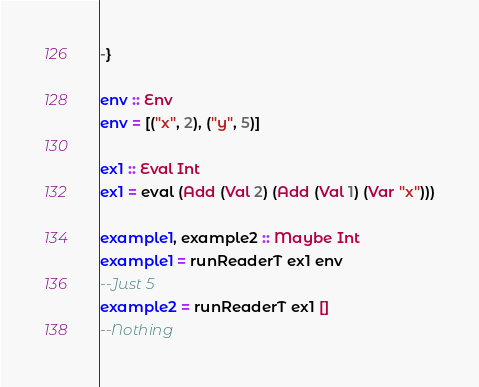Convert code to text. <code><loc_0><loc_0><loc_500><loc_500><_Haskell_>-}

env :: Env
env = [("x", 2), ("y", 5)]

ex1 :: Eval Int
ex1 = eval (Add (Val 2) (Add (Val 1) (Var "x")))

example1, example2 :: Maybe Int
example1 = runReaderT ex1 env
--Just 5
example2 = runReaderT ex1 []
--Nothing
</code> 